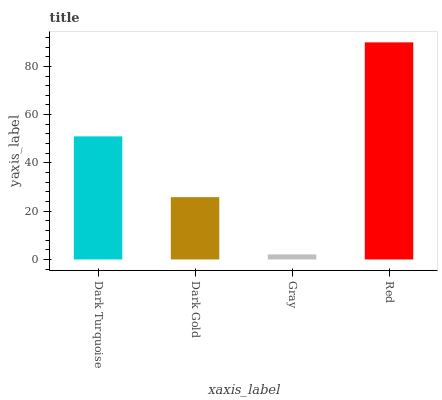Is Gray the minimum?
Answer yes or no. Yes. Is Red the maximum?
Answer yes or no. Yes. Is Dark Gold the minimum?
Answer yes or no. No. Is Dark Gold the maximum?
Answer yes or no. No. Is Dark Turquoise greater than Dark Gold?
Answer yes or no. Yes. Is Dark Gold less than Dark Turquoise?
Answer yes or no. Yes. Is Dark Gold greater than Dark Turquoise?
Answer yes or no. No. Is Dark Turquoise less than Dark Gold?
Answer yes or no. No. Is Dark Turquoise the high median?
Answer yes or no. Yes. Is Dark Gold the low median?
Answer yes or no. Yes. Is Dark Gold the high median?
Answer yes or no. No. Is Gray the low median?
Answer yes or no. No. 